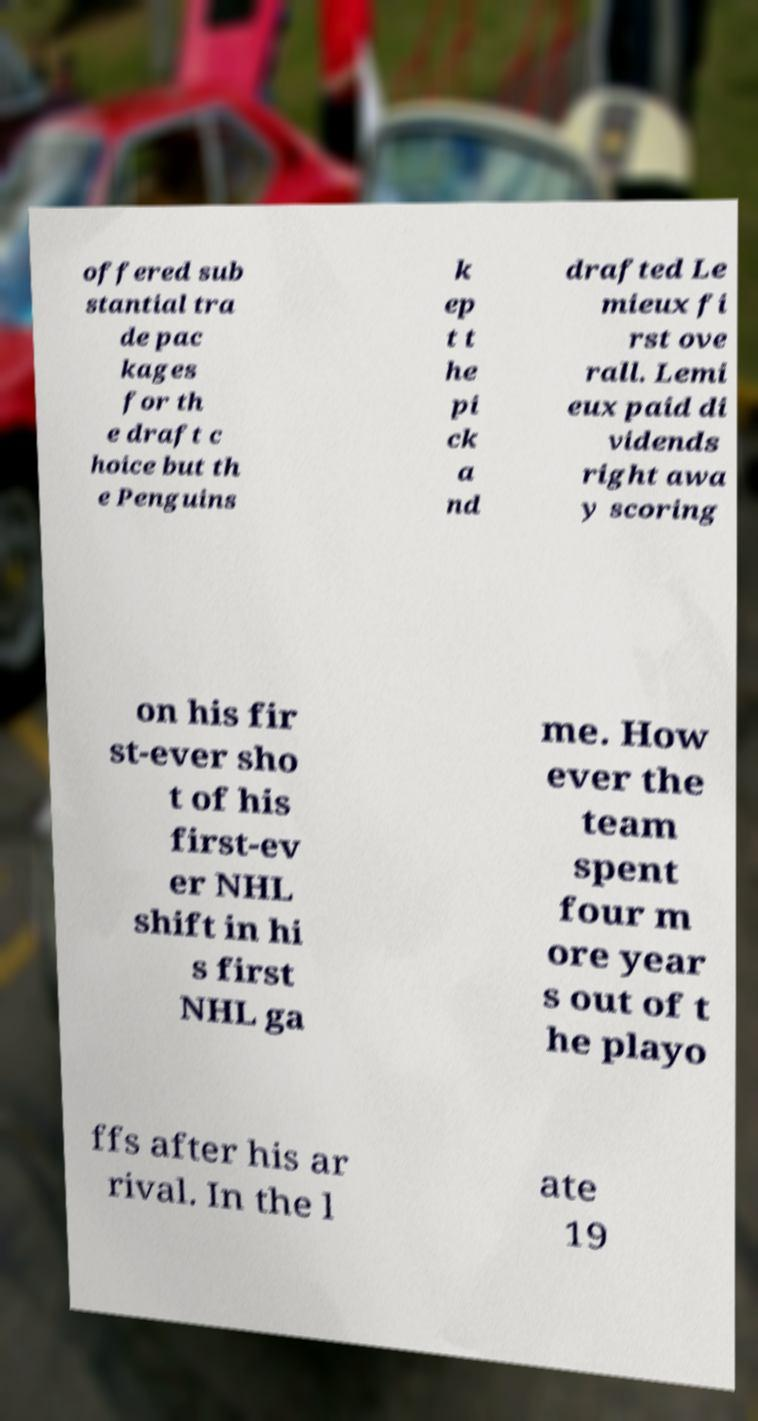There's text embedded in this image that I need extracted. Can you transcribe it verbatim? offered sub stantial tra de pac kages for th e draft c hoice but th e Penguins k ep t t he pi ck a nd drafted Le mieux fi rst ove rall. Lemi eux paid di vidends right awa y scoring on his fir st-ever sho t of his first-ev er NHL shift in hi s first NHL ga me. How ever the team spent four m ore year s out of t he playo ffs after his ar rival. In the l ate 19 